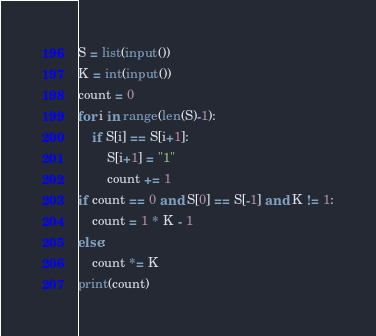Convert code to text. <code><loc_0><loc_0><loc_500><loc_500><_Python_>S = list(input())
K = int(input())
count = 0
for i in range(len(S)-1):
    if S[i] == S[i+1]:
        S[i+1] = "1"
        count += 1
if count == 0 and S[0] == S[-1] and K != 1:
    count = 1 * K - 1
else:
    count *= K
print(count)
</code> 